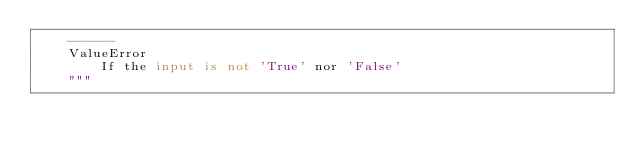Convert code to text. <code><loc_0><loc_0><loc_500><loc_500><_Python_>    ------
    ValueError
        If the input is not 'True' nor 'False'
    """</code> 